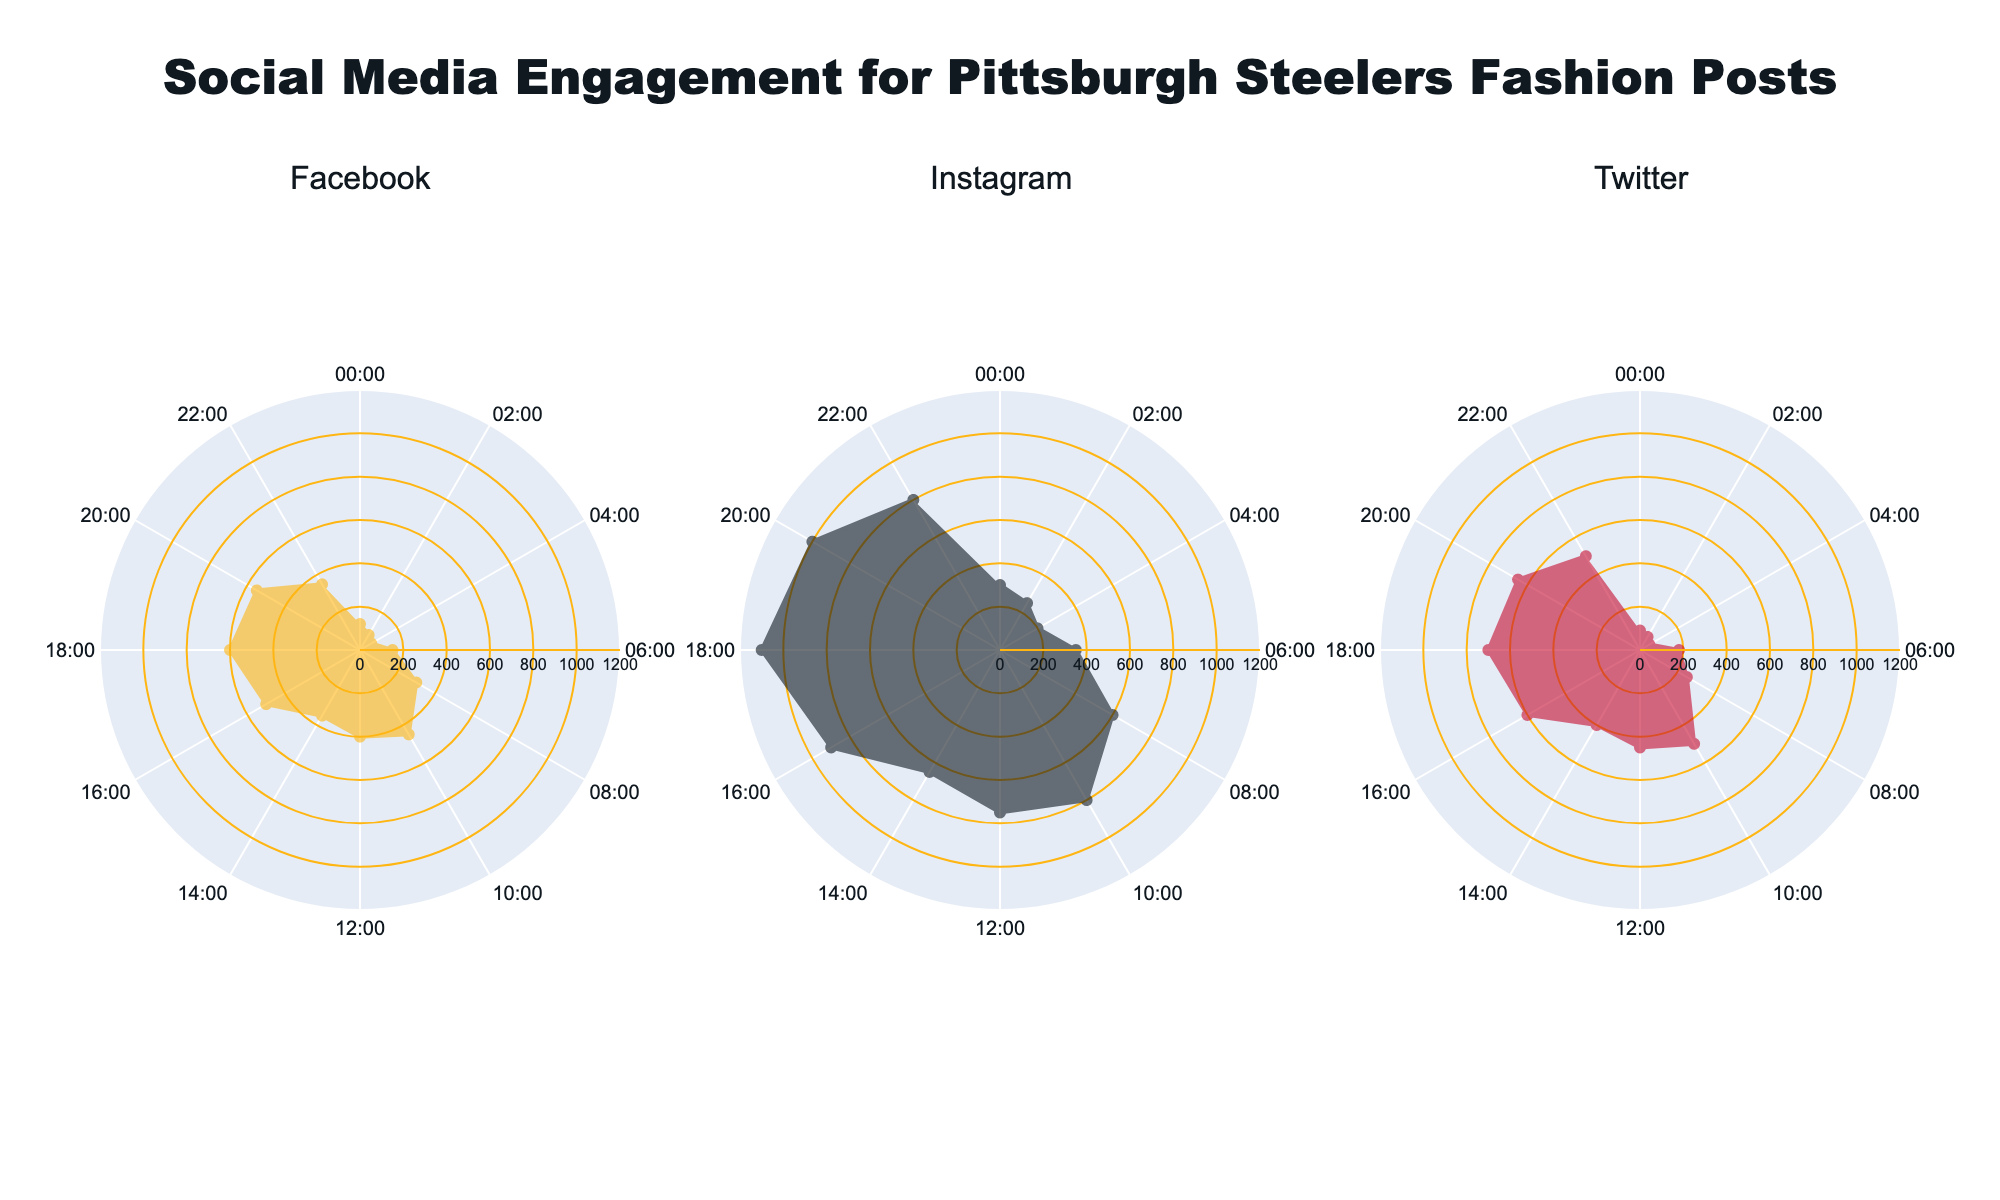1. What is the title of the figure? The title is written at the top center of the figure. It is larger in size and styled in 'Arial Black'.
Answer: Social Media Engagement for Pittsburgh Steelers Fashion Posts 2. How many time intervals are represented in the figure? Each subplot has time labels around the circular axis, starting from "00:00" to "22:00". By counting the labels, we see that there are 12 intervals.
Answer: 12 3. Which platform shows the highest engagement during 18:00-20:00? By inspecting the '18:00-20:00' radial line, check the engagement values in all three subplots. Instagram has the highest engagement.
Answer: Instagram 4. During which time interval does Facebook engagement peak? Locate the highest point in the Facebook engagement subplot and check the corresponding time label. The peak is at 18:00-20:00.
Answer: 18:00-20:00 5. What is the color used to represent Twitter engagement? By looking at the Twitter subplot, the line and fill color of the engagement area is red.
Answer: Red 6. Compare the engagement between Facebook and Twitter during 08:00-10:00. Find the '08:00-10:00' interval for both Facebook and Twitter subplots and compare their engagement values. Facebook is 300, and Twitter is 250. Facebook has higher engagement.
Answer: Facebook 7. Which time interval has the lowest engagement for Instagram? Inspect the radial line values in the Instagram subplot to find the lowest engagement value, which is 200 during 04:00-06:00.
Answer: 04:00-06:00 8. What is the approximate average engagement for Twitter across all intervals? Sum the engagement values across all intervals for Twitter and then divide by the number of intervals. (90+70+50+180+250+500+450+400+600+700+650+500) / 12 = 3900 / 12 = 325
Answer: 325 9. How does Instagram engagement at 10:00-12:00 compare to Facebook engagement at the same time? Check the engagement value of the '10:00-12:00' interval for both Instagram (800) and Facebook (450); Instagram has higher engagement.
Answer: Instagram 10. What is the total engagement for Facebook from 16:00 to 18:00? Find and add the Facebook engagement values for the interval '16:00-18:00' which is 500.
Answer: 500 